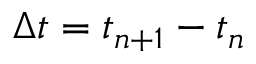Convert formula to latex. <formula><loc_0><loc_0><loc_500><loc_500>\Delta t = t _ { n + 1 } - t _ { n }</formula> 